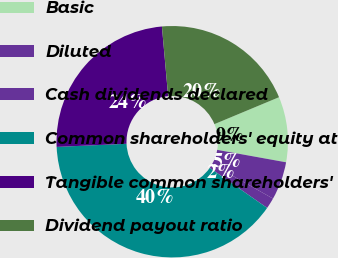Convert chart. <chart><loc_0><loc_0><loc_500><loc_500><pie_chart><fcel>Basic<fcel>Diluted<fcel>Cash dividends declared<fcel>Common shareholders' equity at<fcel>Tangible common shareholders'<fcel>Dividend payout ratio<nl><fcel>9.13%<fcel>5.33%<fcel>1.52%<fcel>39.59%<fcel>24.29%<fcel>20.13%<nl></chart> 